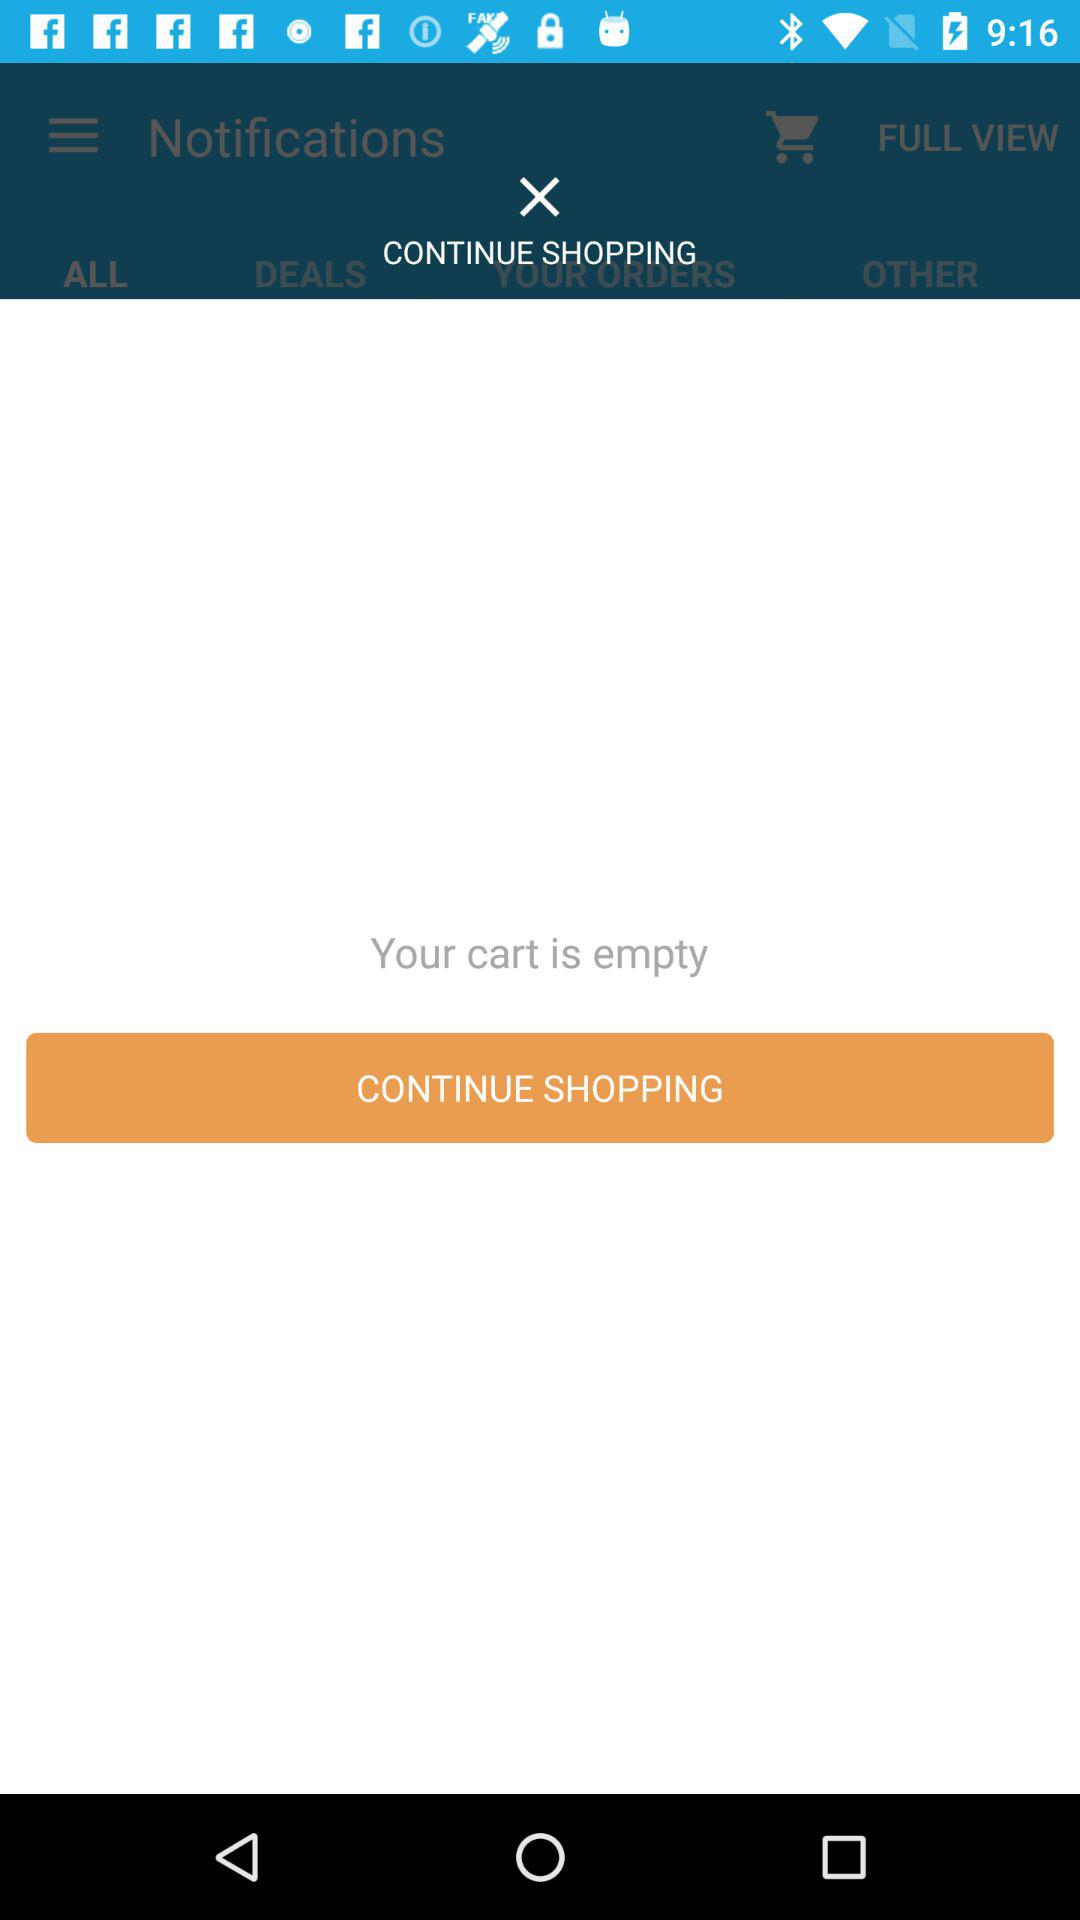Is there any item in the cart? The cart is empty. 